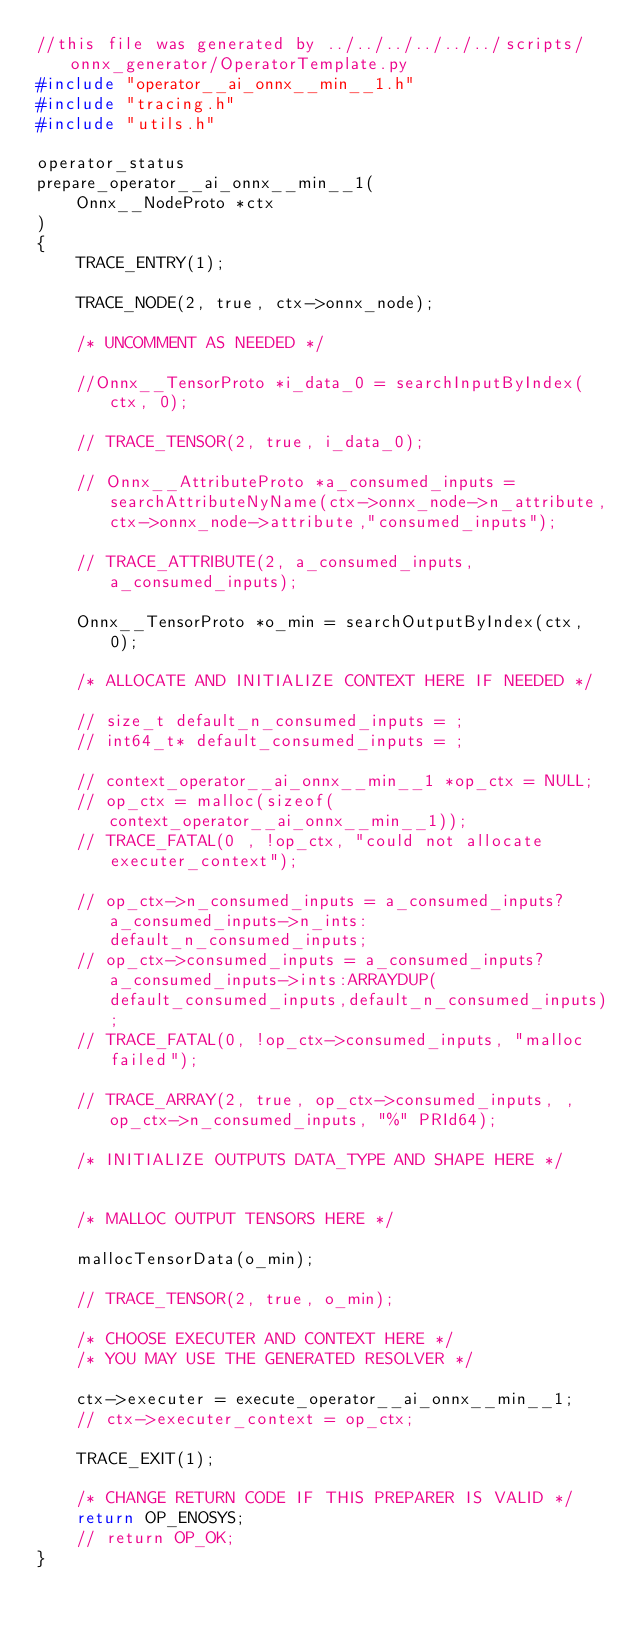Convert code to text. <code><loc_0><loc_0><loc_500><loc_500><_C_>//this file was generated by ../../../../../../scripts/onnx_generator/OperatorTemplate.py
#include "operator__ai_onnx__min__1.h"
#include "tracing.h"
#include "utils.h"

operator_status
prepare_operator__ai_onnx__min__1(
    Onnx__NodeProto *ctx
)
{
    TRACE_ENTRY(1);

    TRACE_NODE(2, true, ctx->onnx_node);

    /* UNCOMMENT AS NEEDED */

    //Onnx__TensorProto *i_data_0 = searchInputByIndex(ctx, 0);

    // TRACE_TENSOR(2, true, i_data_0);

    // Onnx__AttributeProto *a_consumed_inputs = searchAttributeNyName(ctx->onnx_node->n_attribute,ctx->onnx_node->attribute,"consumed_inputs");

    // TRACE_ATTRIBUTE(2, a_consumed_inputs, a_consumed_inputs);

    Onnx__TensorProto *o_min = searchOutputByIndex(ctx, 0);

    /* ALLOCATE AND INITIALIZE CONTEXT HERE IF NEEDED */

    // size_t default_n_consumed_inputs = ;
    // int64_t* default_consumed_inputs = ;

    // context_operator__ai_onnx__min__1 *op_ctx = NULL;
    // op_ctx = malloc(sizeof(context_operator__ai_onnx__min__1));
    // TRACE_FATAL(0 , !op_ctx, "could not allocate executer_context");

    // op_ctx->n_consumed_inputs = a_consumed_inputs?a_consumed_inputs->n_ints:default_n_consumed_inputs;
    // op_ctx->consumed_inputs = a_consumed_inputs?a_consumed_inputs->ints:ARRAYDUP(default_consumed_inputs,default_n_consumed_inputs);
    // TRACE_FATAL(0, !op_ctx->consumed_inputs, "malloc failed");

    // TRACE_ARRAY(2, true, op_ctx->consumed_inputs, , op_ctx->n_consumed_inputs, "%" PRId64);

    /* INITIALIZE OUTPUTS DATA_TYPE AND SHAPE HERE */


    /* MALLOC OUTPUT TENSORS HERE */

    mallocTensorData(o_min);

    // TRACE_TENSOR(2, true, o_min);

    /* CHOOSE EXECUTER AND CONTEXT HERE */
    /* YOU MAY USE THE GENERATED RESOLVER */

    ctx->executer = execute_operator__ai_onnx__min__1;
    // ctx->executer_context = op_ctx;

    TRACE_EXIT(1);

    /* CHANGE RETURN CODE IF THIS PREPARER IS VALID */
    return OP_ENOSYS;
    // return OP_OK;
}</code> 